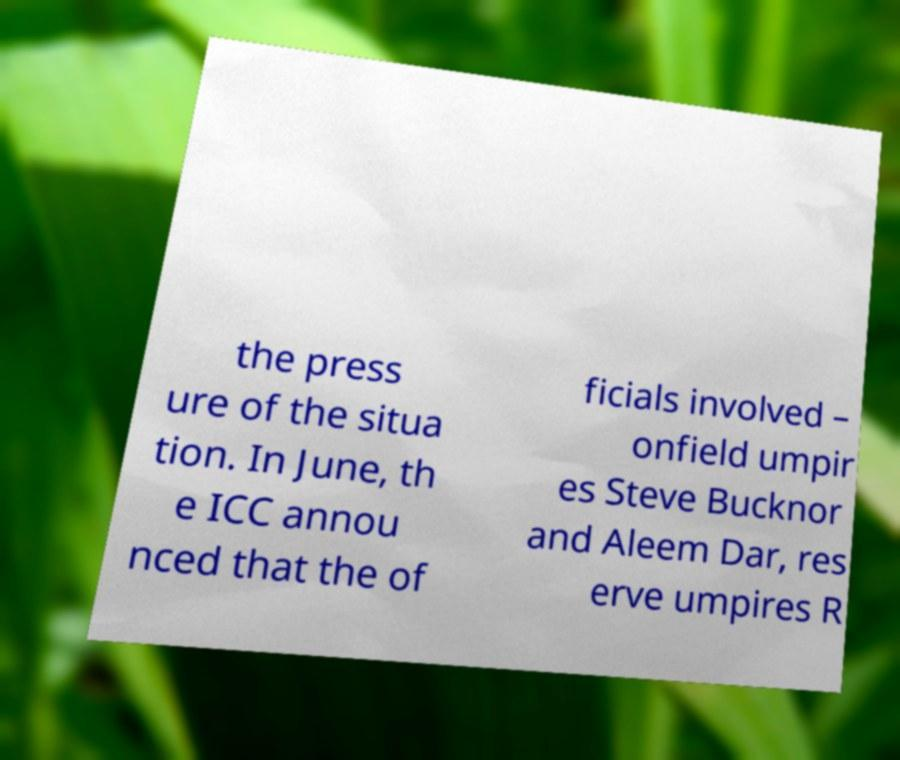Please read and relay the text visible in this image. What does it say? the press ure of the situa tion. In June, th e ICC annou nced that the of ficials involved – onfield umpir es Steve Bucknor and Aleem Dar, res erve umpires R 